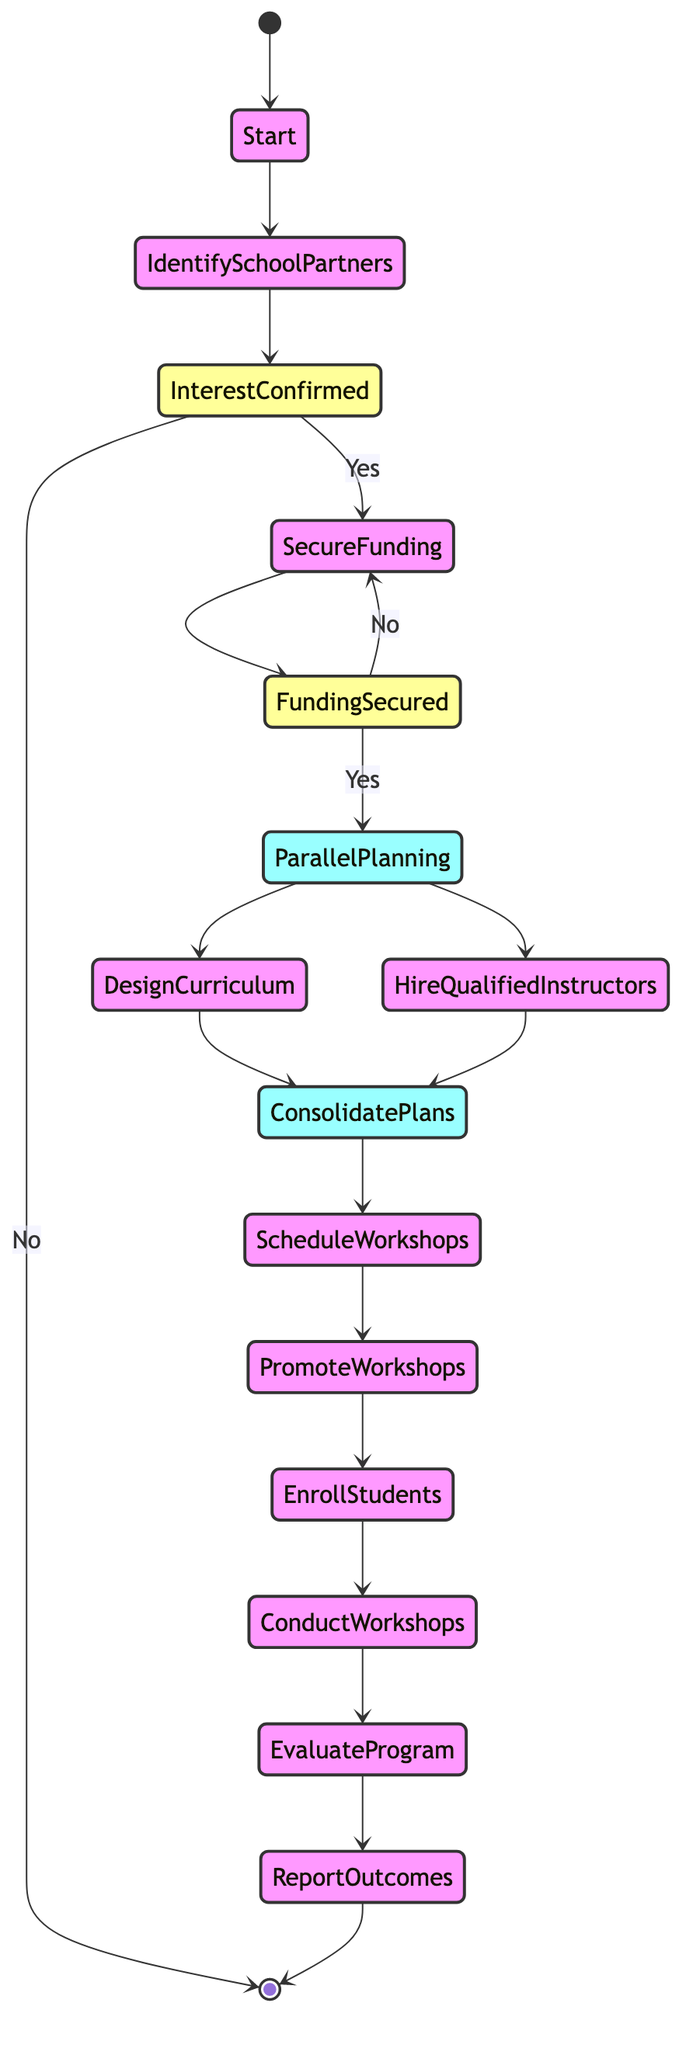What is the starting point of the process? The diagram identifies "Start" as the initial node where the implementation process begins, indicating the first activity in the sequence.
Answer: Start How many decision nodes are present in the diagram? The diagram includes two decision nodes: "Interest Confirmed?" and "Funding Secured?" This means that there are two points where a decision must be made based on a yes or no answer.
Answer: 2 What are the activities that occur in parallel during the planning phase? The parallel activities listed in the diagram under "Parallel Planning" are "Design Curriculum" and "Hire Qualified Instructors." These activities take place simultaneously before merging back into a single process.
Answer: Design Curriculum and Hire Qualified Instructors What happens if local schools are not interested in participation? According to the diagram, if schools are not interested ("Interest Confirmed? No"), the process redirects back to the initial node, indicating no further action in the current implementation phase.
Answer: No further action At which point do the plans for curriculum design and instructor hiring merge? The diagram reveals the merging point as "Consolidate Plans," where the paths from both "Design Curriculum" and "Hire Qualified Instructors" converge for subsequent activities.
Answer: Consolidate Plans What is the final outcome reported to stakeholders? The final output indicated in the diagram is the "Report Outcomes," which summarizes the impact and benefits of the programs conducted throughout the workshops.
Answer: Report Outcomes How do we determine if there's enough funding for the workshops? The diagram specifies that a decision must be made at the "Funding Secured?" node, where if funding is not secured ("No"), the path loops back to the "Secure Funding" activity until sufficient funding is confirmed.
Answer: Funding Secured? After conducting the workshops, what is the subsequent activity? The next activity after "Conduct Workshops" is "Evaluate Program," which involves collecting feedback and measuring the success of the implementation.
Answer: Evaluate Program What represents the end of the implementation process? The diagram concludes with the "End" node, which signifies the completion of the entire process and indicates that all activities are finalized.
Answer: End 